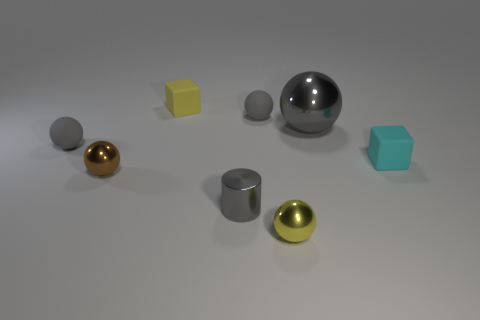Subtract all green cubes. How many gray spheres are left? 3 Subtract all yellow spheres. How many spheres are left? 4 Subtract all big gray balls. How many balls are left? 4 Subtract all blue spheres. Subtract all cyan blocks. How many spheres are left? 5 Add 1 brown metal spheres. How many objects exist? 9 Subtract all blocks. How many objects are left? 6 Subtract 0 cyan cylinders. How many objects are left? 8 Subtract all tiny red matte cylinders. Subtract all brown spheres. How many objects are left? 7 Add 8 big metal things. How many big metal things are left? 9 Add 4 brown cylinders. How many brown cylinders exist? 4 